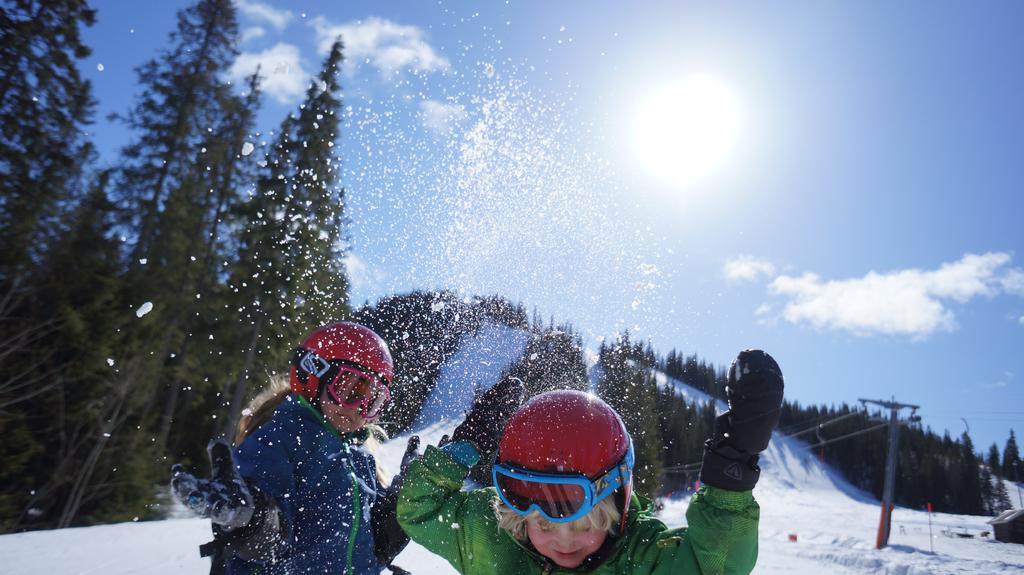How many children are in the image? There are two children in the image. What are the children wearing? One child is wearing a blue dress and a red helmet, while the other child is wearing a red dress and a red helmet. What can be seen in the background of the image? There is snow, a pole, trees, and the sky visible in the background of the image. What type of honey can be seen dripping from the pole in the image? There is no honey present in the image; the pole is in the snowy background without any honey. What can be seen from the view of the children in the image? The view from the children's perspective cannot be determined from the image, as it only shows the children and the background elements. 